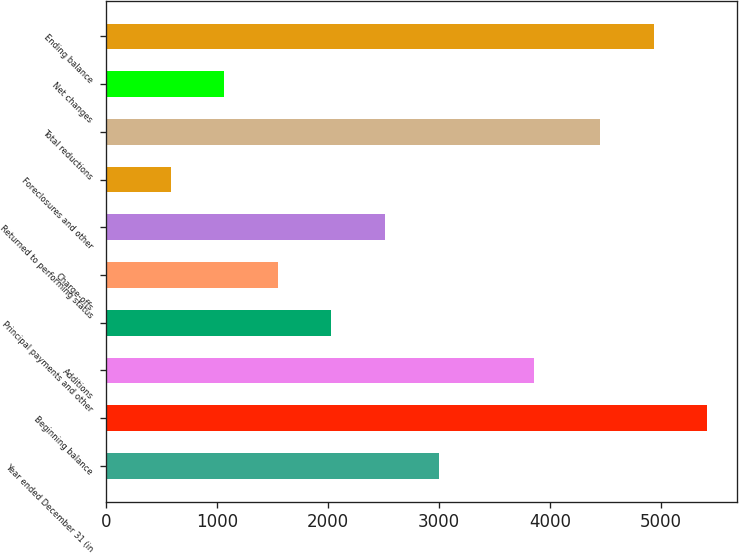Convert chart to OTSL. <chart><loc_0><loc_0><loc_500><loc_500><bar_chart><fcel>Year ended December 31 (in<fcel>Beginning balance<fcel>Additions<fcel>Principal payments and other<fcel>Charge-offs<fcel>Returned to performing status<fcel>Foreclosures and other<fcel>Total reductions<fcel>Net changes<fcel>Ending balance<nl><fcel>2997.5<fcel>5417.2<fcel>3858<fcel>2031.3<fcel>1548.2<fcel>2514.4<fcel>582<fcel>4451<fcel>1065.1<fcel>4934.1<nl></chart> 